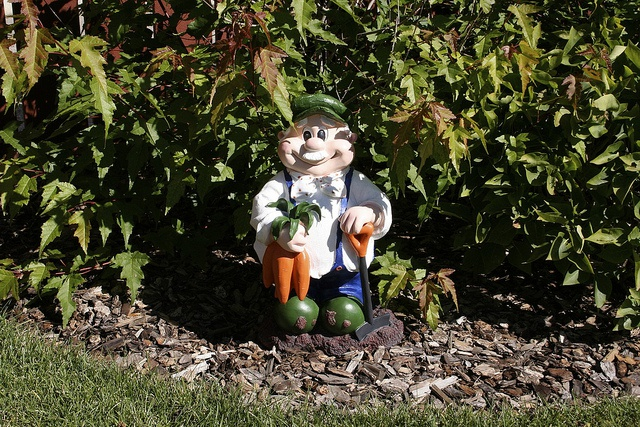Describe the objects in this image and their specific colors. I can see carrot in maroon, red, black, and orange tones and carrot in maroon, orange, and red tones in this image. 